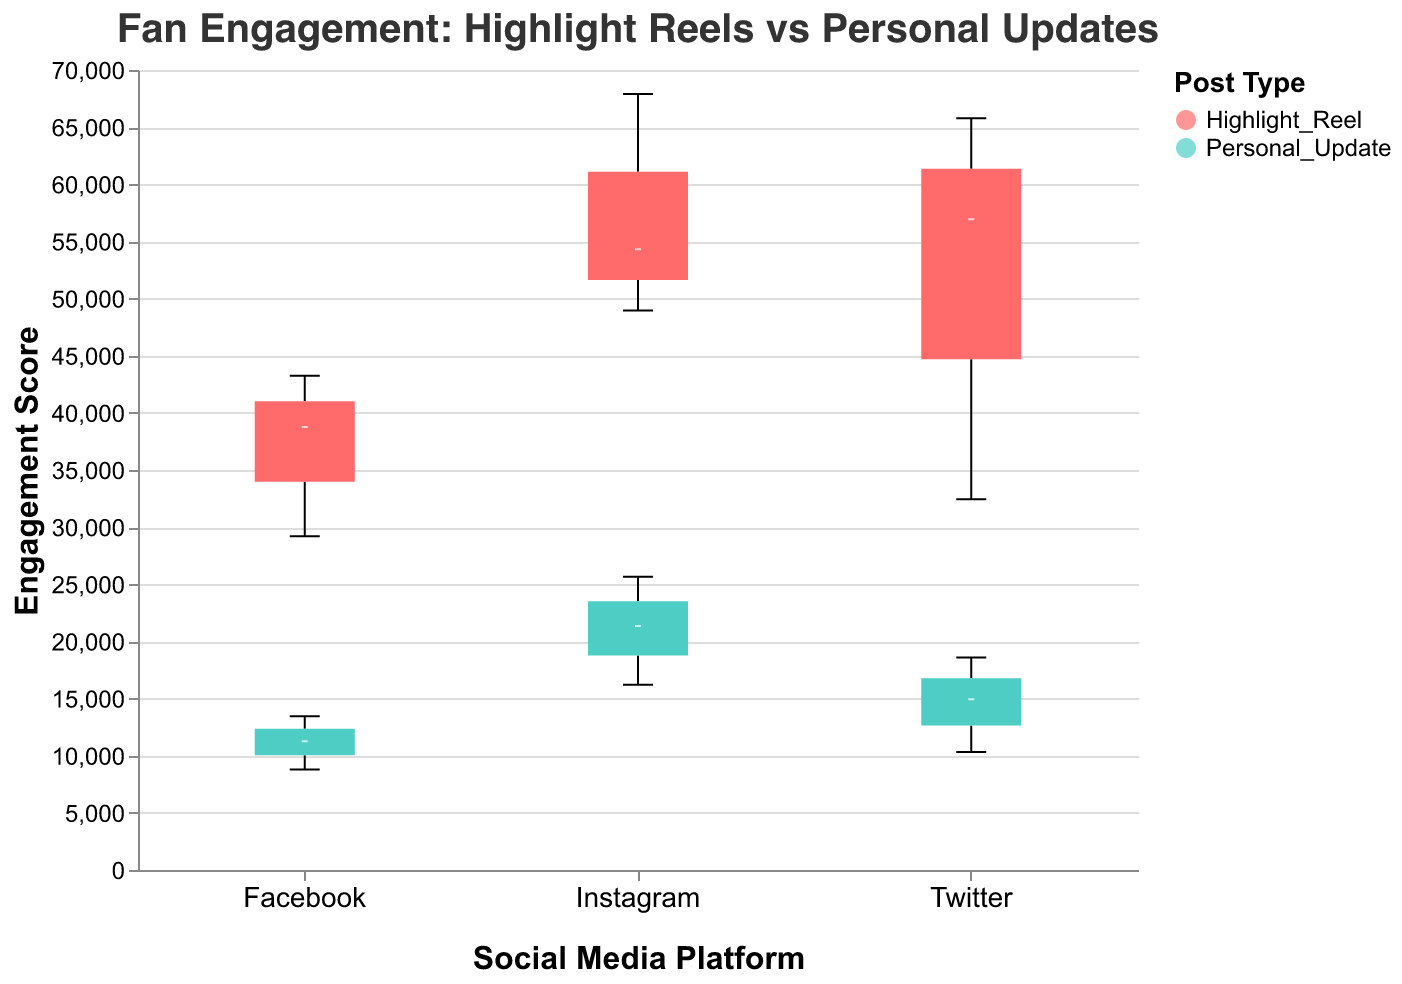What is the title of the figure? The title is at the top of the figure, set in a larger and distinct font to summarize the plot's content.
Answer: Fan Engagement: Highlight Reels vs Personal Updates Which social media platform provides the highest median engagement score for Highlight Reel posts? By observing the boxes representing Highlight Reel posts on each social media platform, the box with the highest median line reveals this information.
Answer: Instagram What color represents Personal Update posts in the figure? The color indicated in the legend for Personal Update posts provides this information.
Answer: Turquoise/Teal Between Twitter and Facebook, which platform has a greater range of engagement scores for Personal Update posts? The range of engagement scores can be assessed by the vertical length of the boxplots for each platform. Comparing the boxes for Twitter and Facebook Personal Updates shows which is longer.
Answer: Twitter How does the median engagement score for Highlight Reels on Facebook compare to that on Twitter? The median engagement score can be seen as the line inside each box. Comparing lines for Highlight Reels on Facebook and Twitter reveals which is higher.
Answer: Higher on Twitter Compared to Highlight Reels on Instagram, what is the approximate difference in the median engagement scores of Personal Updates on Instagram? Evaluate the median lines inside the respective boxes for Highlight Reels and Personal Updates on Instagram and calculate the difference.
Answer: Approximately 48,780 Which platform shows the lowest minimum engagement score for Personal Updates? The minimum engagement score for Personal Updates is indicated by the bottom whisker of the corresponding boxes.
Answer: Facebook In terms of overall engagement, how do Highlight Reel posts perform compared to Personal Updates on Instagram? Observing the range, median, and overall distribution of the boxes for both post types on Instagram gives insights into performance.
Answer: Highlight Reels perform much better What is the highest maximum engagement score observed in the figure, and for which type of post and platform? The highest maximum engagement score is represented by the topmost whisker across all boxplots. Identifying the boxplot helps determine the post type and platform.
Answer: 67,890 for Highlight Reel on Instagram Which post type has a more consistent engagement pattern on Twitter, and how is this identified? Consistency can be seen by looking at the spread of the scores within the boxes. A smaller interquartile range (IQR) suggests more consistency.
Answer: Personal Update (smaller IQR) 